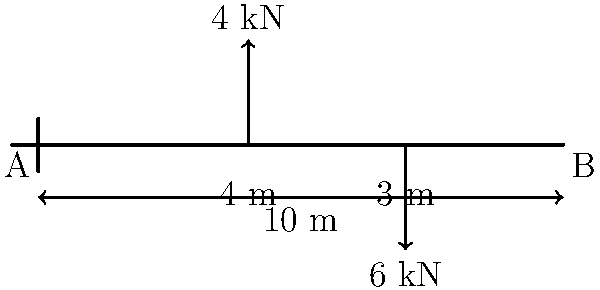In the spirit of deconstructing traditional narratives, consider a cantilever beam subjected to forces that challenge its equilibrium. The beam, spanning 10 meters, experiences an upward force of 4 kN at 4 meters from the fixed end and a downward force of 6 kN at 7 meters. What is the magnitude of the bending moment at the fixed end? Let's approach this problem through a postmodern lens, deconstructing it step by step:

1) First, we need to understand that the bending moment at the fixed end is a result of the forces acting on the beam and their distances from the fixed end.

2) In this case, we have two forces:
   - An upward force of 4 kN at 4 meters from the fixed end
   - A downward force of 6 kN at 7 meters from the fixed end

3) The bending moment caused by each force is the product of the force and its perpendicular distance from the point of interest (in this case, the fixed end).

4) For the 4 kN force:
   Moment = 4 kN * 4 m = 16 kN·m (clockwise)

5) For the 6 kN force:
   Moment = 6 kN * 7 m = 42 kN·m (counter-clockwise)

6) The total bending moment is the algebraic sum of these individual moments. We typically consider counter-clockwise moments as positive:

   Total Moment = -16 kN·m + 42 kN·m = 26 kN·m

7) Therefore, the magnitude of the bending moment at the fixed end is 26 kN·m.

This deconstruction reveals how seemingly disparate forces coalesce to create a singular effect, much like how various literary elements come together to form a postmodern narrative.
Answer: 26 kN·m 